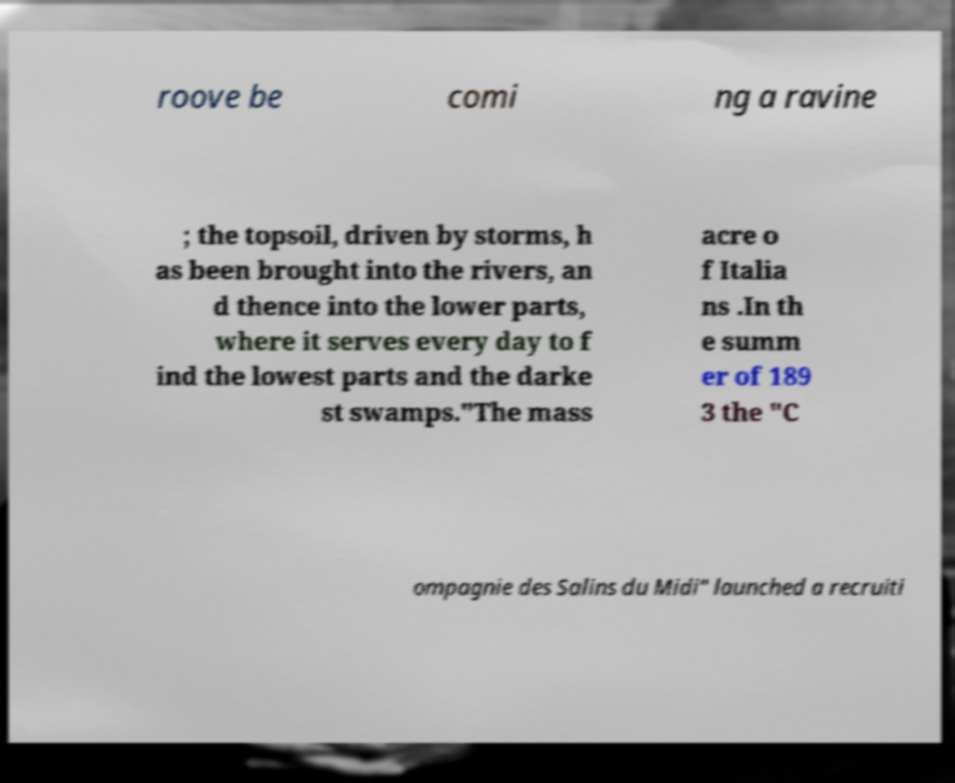There's text embedded in this image that I need extracted. Can you transcribe it verbatim? roove be comi ng a ravine ; the topsoil, driven by storms, h as been brought into the rivers, an d thence into the lower parts, where it serves every day to f ind the lowest parts and the darke st swamps."The mass acre o f Italia ns .In th e summ er of 189 3 the "C ompagnie des Salins du Midi" launched a recruiti 